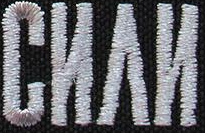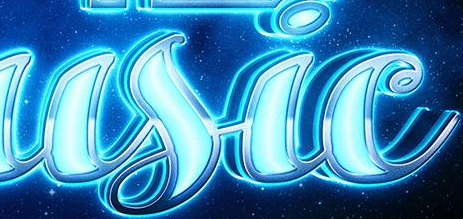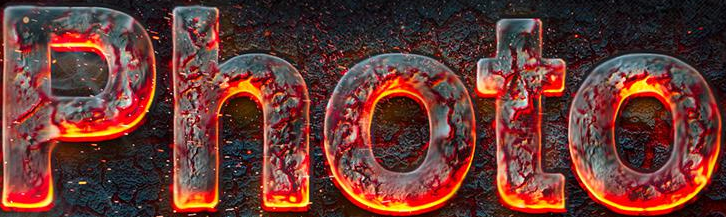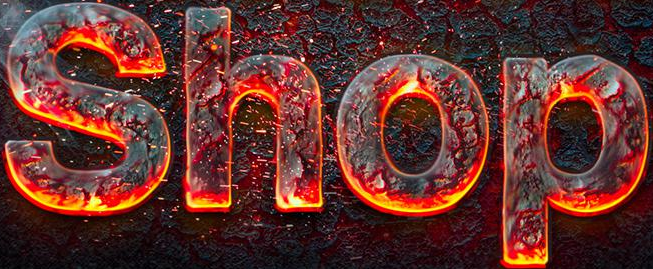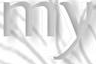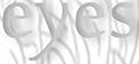Read the text content from these images in order, separated by a semicolon. CИΛИ; usic; Photo; Shop; my; eyes 